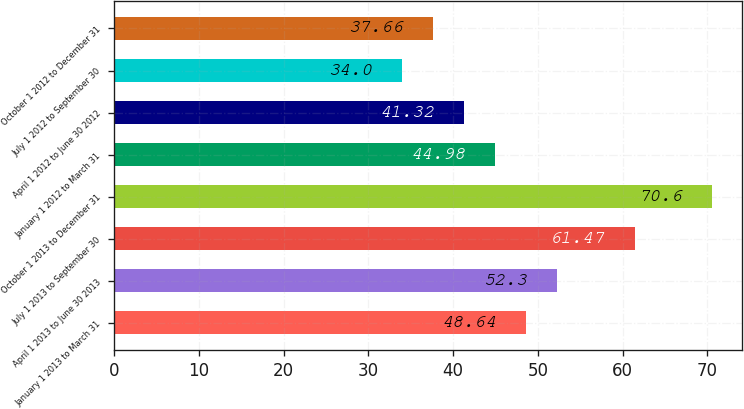Convert chart. <chart><loc_0><loc_0><loc_500><loc_500><bar_chart><fcel>January 1 2013 to March 31<fcel>April 1 2013 to June 30 2013<fcel>July 1 2013 to September 30<fcel>October 1 2013 to December 31<fcel>January 1 2012 to March 31<fcel>April 1 2012 to June 30 2012<fcel>July 1 2012 to September 30<fcel>October 1 2012 to December 31<nl><fcel>48.64<fcel>52.3<fcel>61.47<fcel>70.6<fcel>44.98<fcel>41.32<fcel>34<fcel>37.66<nl></chart> 